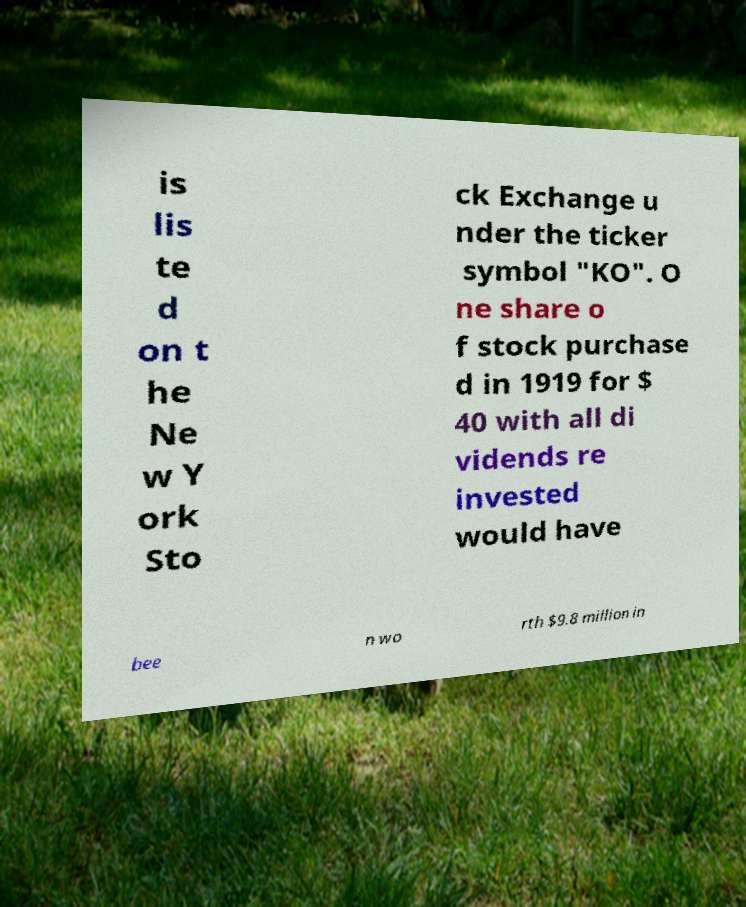Please identify and transcribe the text found in this image. is lis te d on t he Ne w Y ork Sto ck Exchange u nder the ticker symbol "KO". O ne share o f stock purchase d in 1919 for $ 40 with all di vidends re invested would have bee n wo rth $9.8 million in 